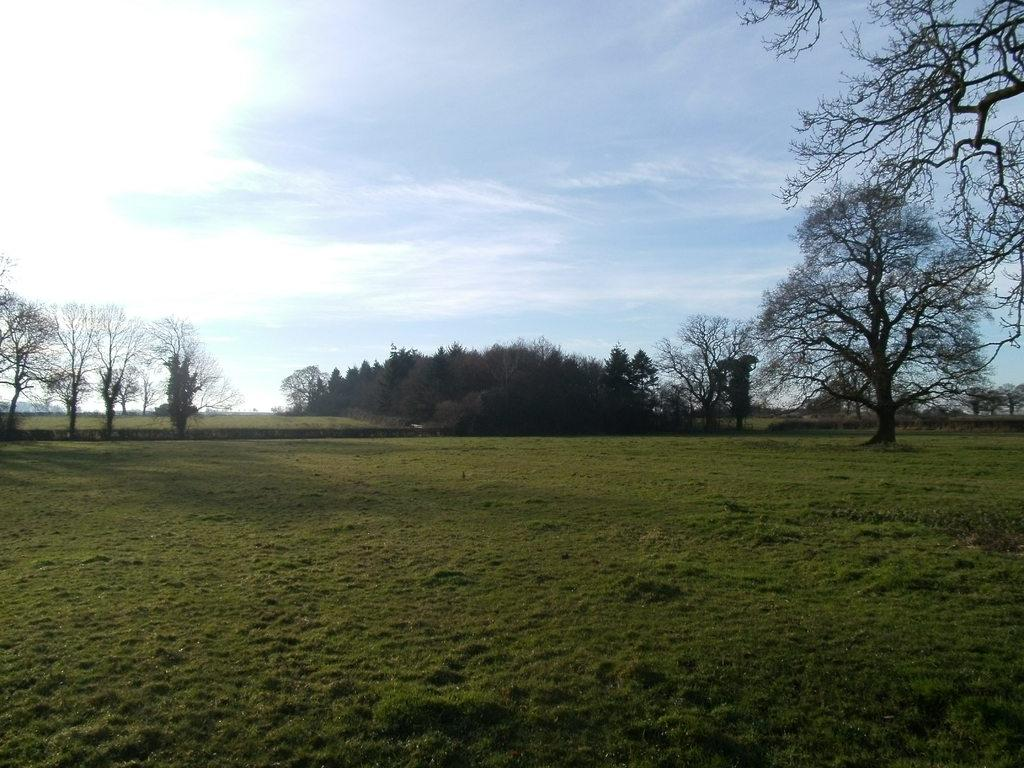What type of vegetation can be seen in the image? There are trees in the image. What part of the natural environment is visible in the image? The sky is visible in the image. What type of ground cover is present at the bottom of the image? There is grass at the bottom of the image. What level of anger can be observed in the trees in the image? There is no indication of anger in the image, as trees are inanimate objects and do not experience emotions. 